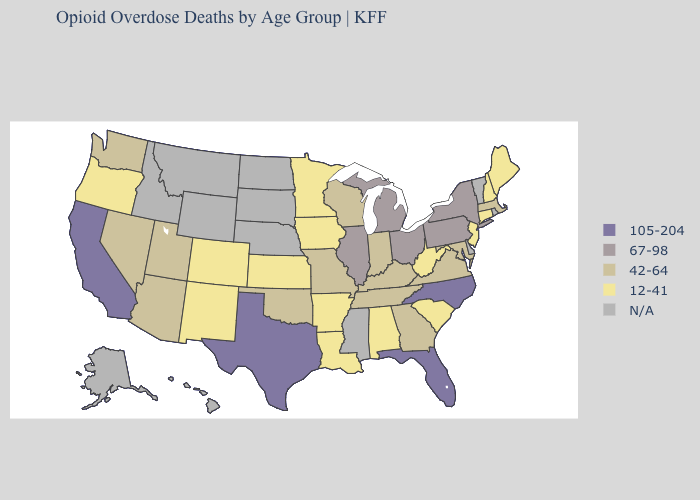What is the value of Kentucky?
Short answer required. 42-64. Which states have the lowest value in the West?
Give a very brief answer. Colorado, New Mexico, Oregon. Name the states that have a value in the range N/A?
Write a very short answer. Alaska, Delaware, Hawaii, Idaho, Mississippi, Montana, Nebraska, North Dakota, Rhode Island, South Dakota, Vermont, Wyoming. Among the states that border Iowa , does Minnesota have the lowest value?
Short answer required. Yes. Which states have the lowest value in the USA?
Write a very short answer. Alabama, Arkansas, Colorado, Connecticut, Iowa, Kansas, Louisiana, Maine, Minnesota, New Hampshire, New Jersey, New Mexico, Oregon, South Carolina, West Virginia. Which states have the highest value in the USA?
Concise answer only. California, Florida, North Carolina, Texas. Does Indiana have the lowest value in the MidWest?
Concise answer only. No. What is the value of Alaska?
Keep it brief. N/A. Does California have the lowest value in the West?
Short answer required. No. Which states have the highest value in the USA?
Short answer required. California, Florida, North Carolina, Texas. Among the states that border Kentucky , does Ohio have the highest value?
Quick response, please. Yes. Which states hav the highest value in the Northeast?
Give a very brief answer. New York, Pennsylvania. Which states have the lowest value in the South?
Write a very short answer. Alabama, Arkansas, Louisiana, South Carolina, West Virginia. What is the value of Alaska?
Quick response, please. N/A. 